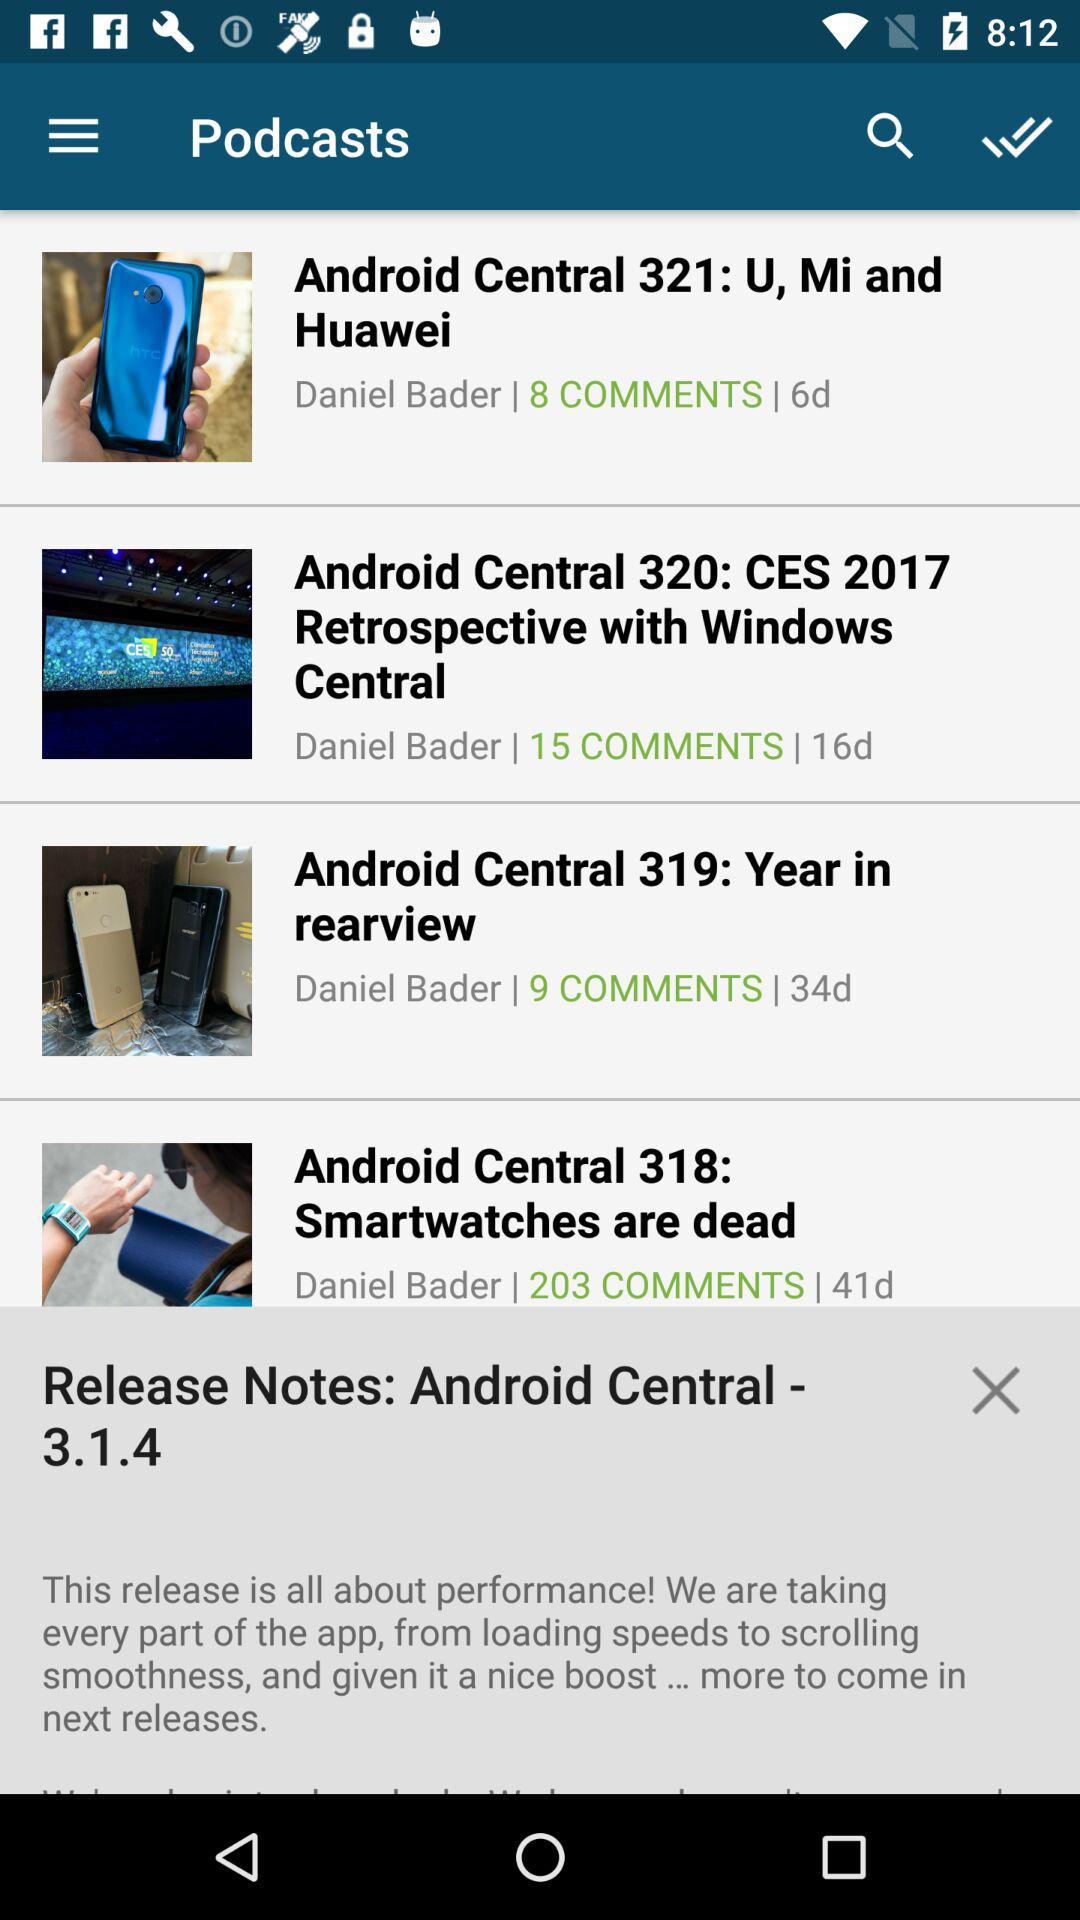How many comments does the most commented episode have?
Answer the question using a single word or phrase. 203 